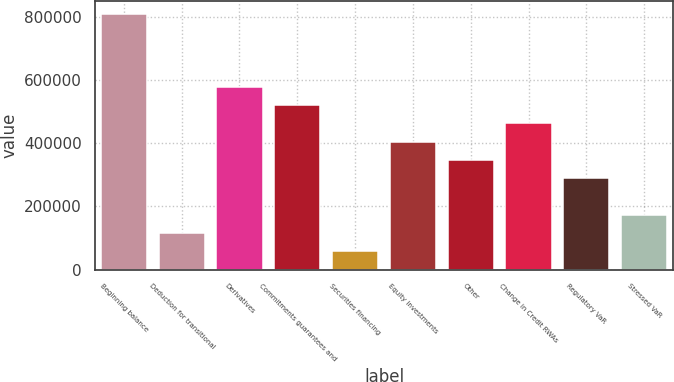Convert chart. <chart><loc_0><loc_0><loc_500><loc_500><bar_chart><fcel>Beginning balance<fcel>Deduction for transitional<fcel>Derivatives<fcel>Commitments guarantees and<fcel>Securities financing<fcel>Equity investments<fcel>Other<fcel>Change in Credit RWAs<fcel>Regulatory VaR<fcel>Stressed VaR<nl><fcel>808645<fcel>115664<fcel>577651<fcel>519903<fcel>57915.4<fcel>404406<fcel>346657<fcel>462154<fcel>288909<fcel>173412<nl></chart> 